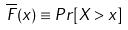<formula> <loc_0><loc_0><loc_500><loc_500>\overline { F } ( x ) \equiv P r [ X > x ]</formula> 